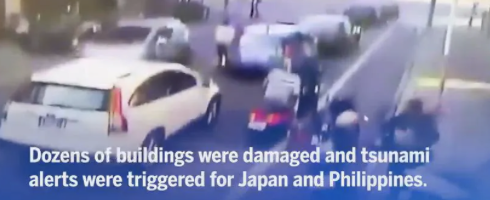read the text in the image 
 Dozens of buildings were damaged and tsunami alerts were triggered for Japan and the Philippines. 